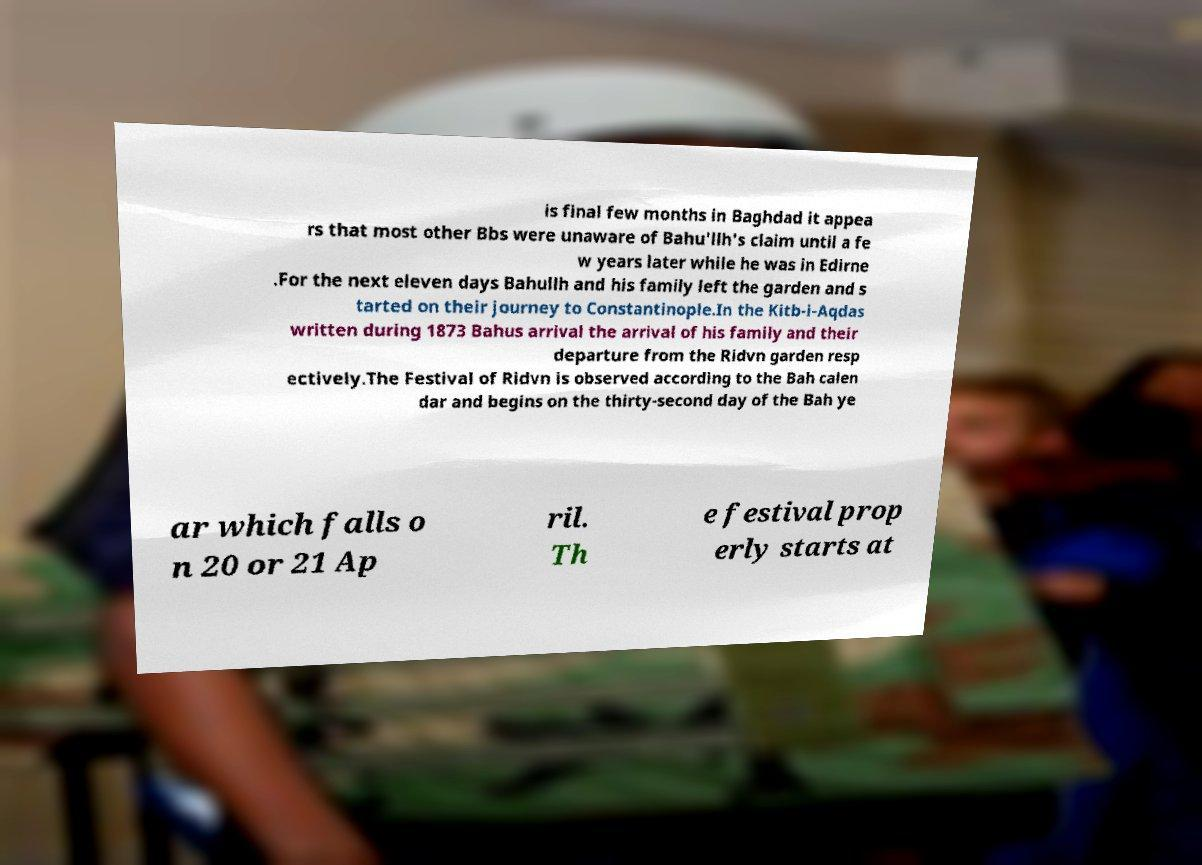Please identify and transcribe the text found in this image. is final few months in Baghdad it appea rs that most other Bbs were unaware of Bahu'llh's claim until a fe w years later while he was in Edirne .For the next eleven days Bahullh and his family left the garden and s tarted on their journey to Constantinople.In the Kitb-i-Aqdas written during 1873 Bahus arrival the arrival of his family and their departure from the Ridvn garden resp ectively.The Festival of Ridvn is observed according to the Bah calen dar and begins on the thirty-second day of the Bah ye ar which falls o n 20 or 21 Ap ril. Th e festival prop erly starts at 